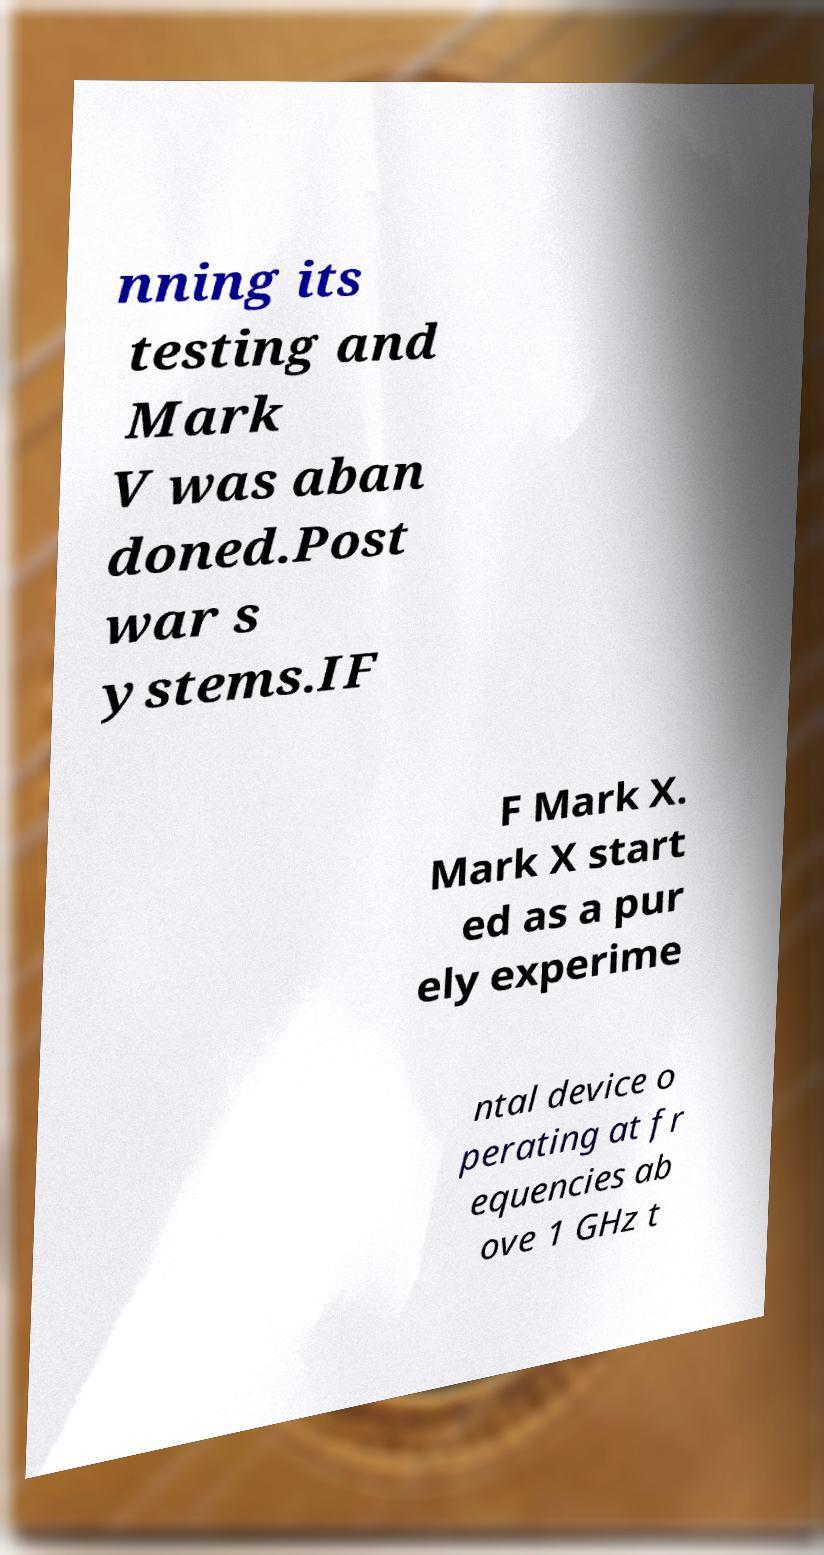What messages or text are displayed in this image? I need them in a readable, typed format. nning its testing and Mark V was aban doned.Post war s ystems.IF F Mark X. Mark X start ed as a pur ely experime ntal device o perating at fr equencies ab ove 1 GHz t 